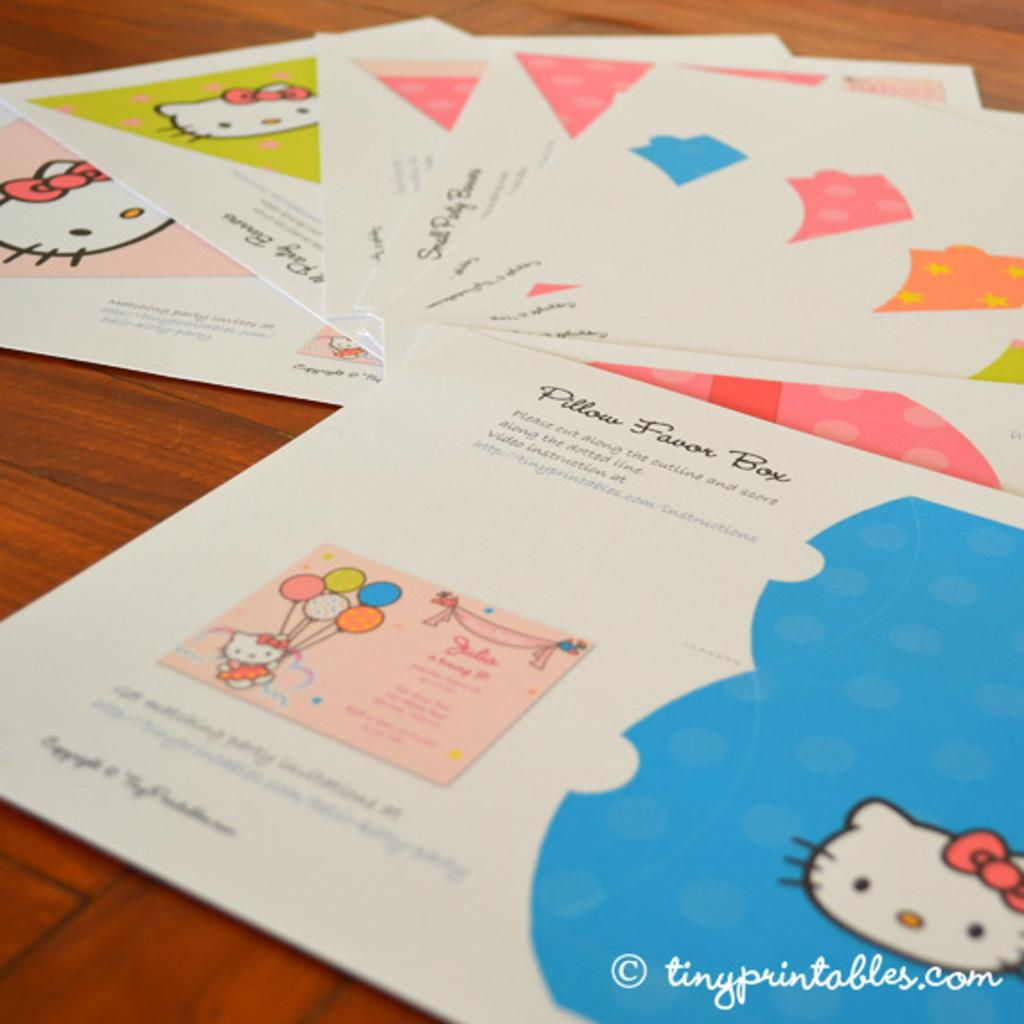<image>
Write a terse but informative summary of the picture. A sweet little Hello Kitty Pillow Favor box for a party. 